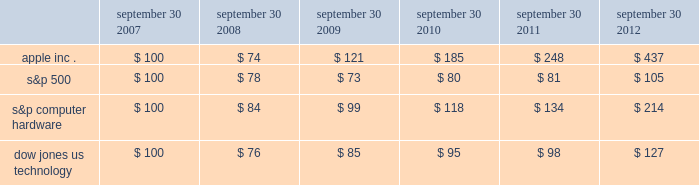Company stock performance the following graph shows a five-year comparison of cumulative total shareholder return , calculated on a dividend reinvested basis , for the company , the s&p 500 composite index , the s&p computer hardware index , and the dow jones u.s .
Technology index .
The graph assumes $ 100 was invested in each of the company 2019s common stock , the s&p 500 composite index , the s&p computer hardware index , and the dow jones u.s .
Technology index as of the market close on september 30 , 2007 .
Data points on the graph are annual .
Note that historic stock price performance is not necessarily indicative of future stock price performance .
Sep-11sep-10sep-09sep-08sep-07 sep-12 apple inc .
S&p 500 s&p computer hardware dow jones us technology comparison of 5 year cumulative total return* among apple inc. , the s&p 500 index , the s&p computer hardware index , and the dow jones us technology index *$ 100 invested on 9/30/07 in stock or index , including reinvestment of dividends .
Fiscal year ending september 30 .
Copyright a9 2012 s&p , a division of the mcgraw-hill companies inc .
All rights reserved .
September 30 , september 30 , september 30 , september 30 , september 30 , september 30 .

What was the difference in the percentage 5 year cumulative total return between apple inc . and thes&p computer hardware for the the period ended september 30 , 2012? 
Computations: (((437 - 100) / 100) - ((214 - 100) / 100))
Answer: 2.23. 